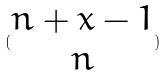<formula> <loc_0><loc_0><loc_500><loc_500>( \begin{matrix} n + x - 1 \\ n \end{matrix} )</formula> 